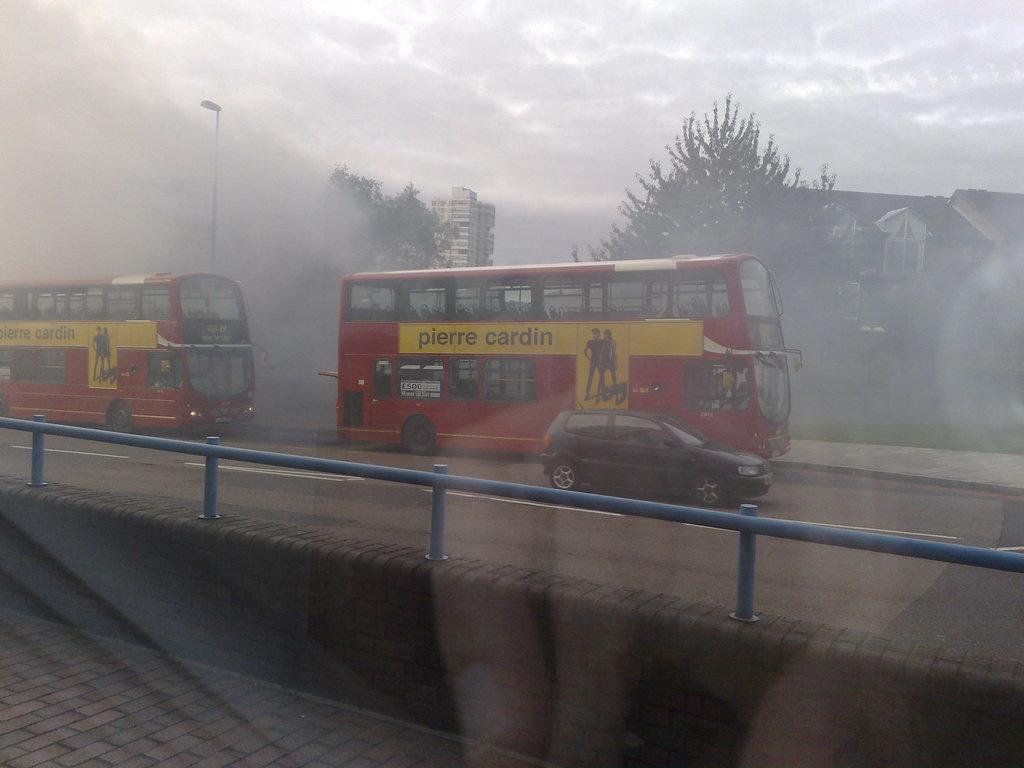What is on the advertisement on the bus?
Keep it short and to the point. Pierre cardin. What number is on the side of the bus?
Offer a very short reply. 500. 